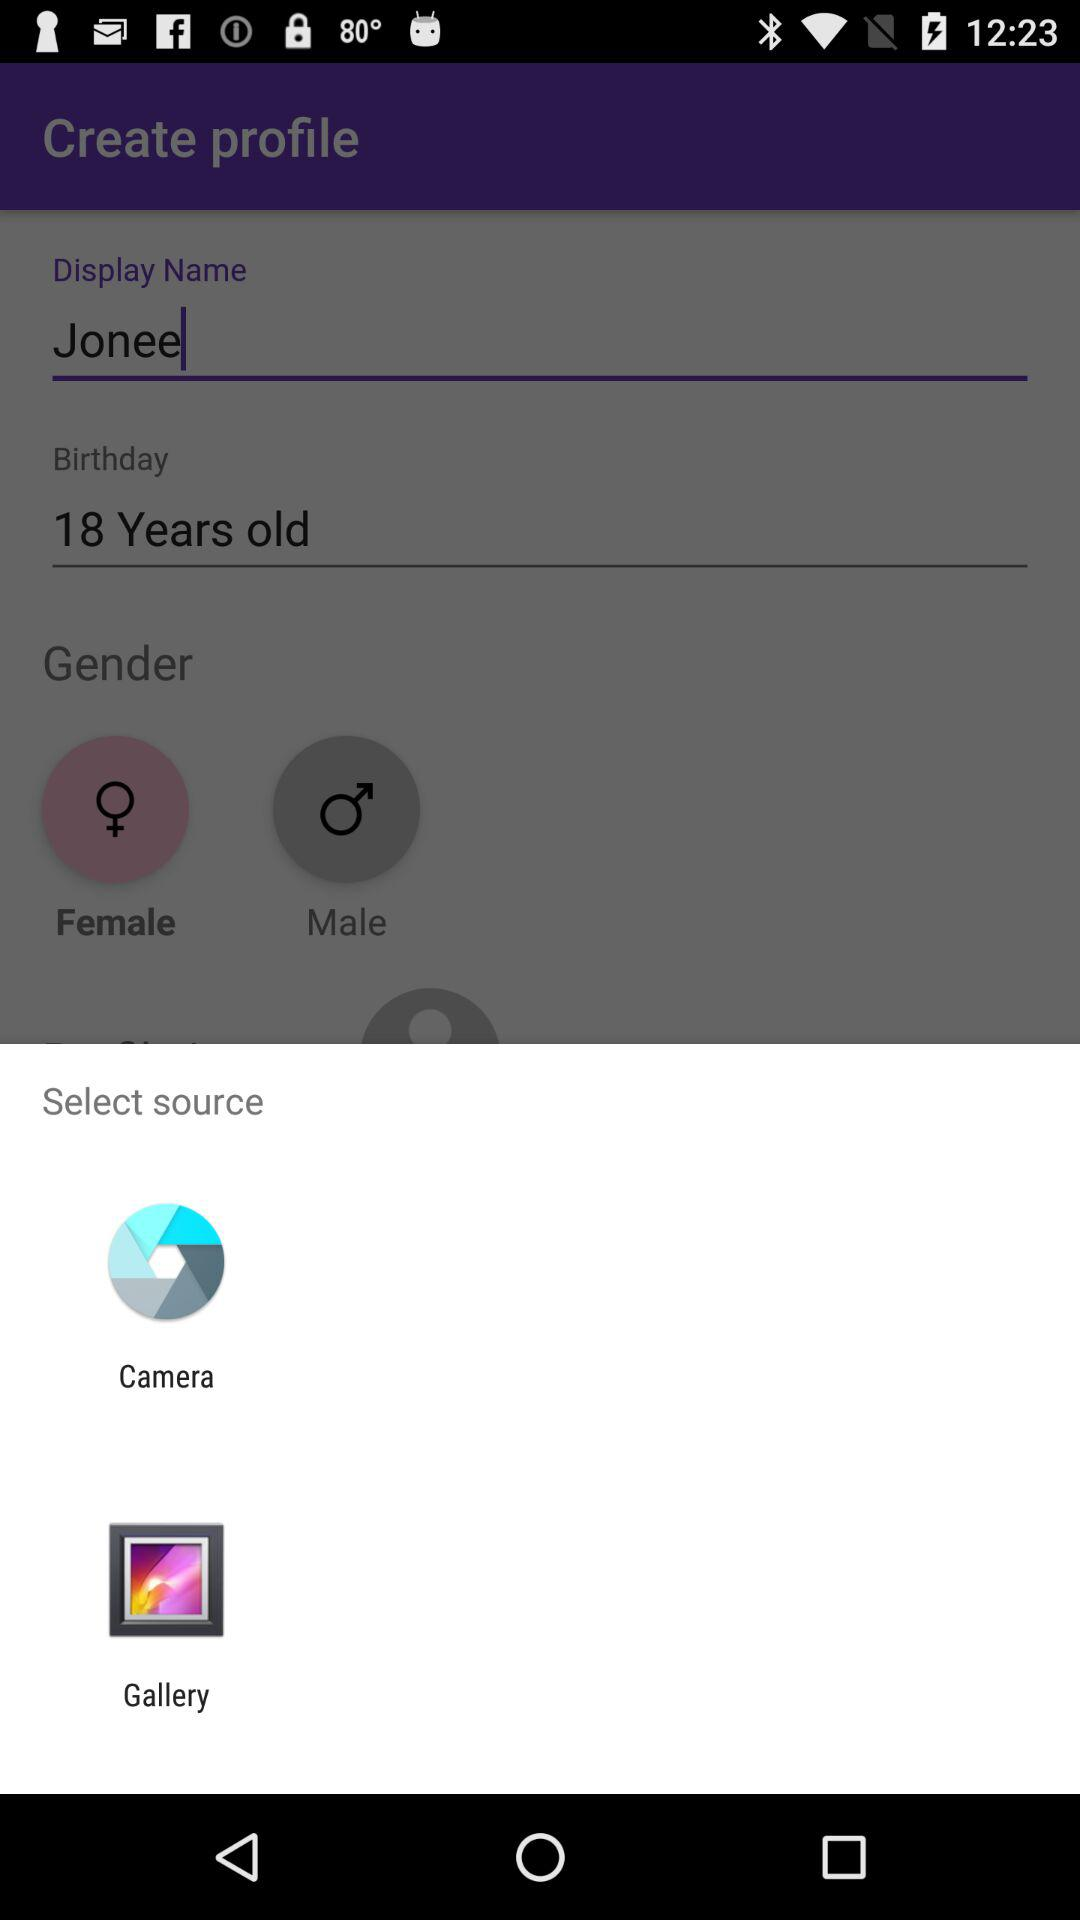Through which app can I upload? You can upload through "Camera" and "Gallery". 